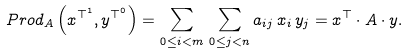<formula> <loc_0><loc_0><loc_500><loc_500>P r o d _ { A } \left ( x ^ { \top ^ { 1 } } , y ^ { \top ^ { 0 } } \right ) = \sum _ { 0 \leq i < m } \, \sum _ { 0 \leq j < n } a _ { i j } \, x _ { i } \, y _ { j } = x ^ { \top } \cdot A \cdot y .</formula> 